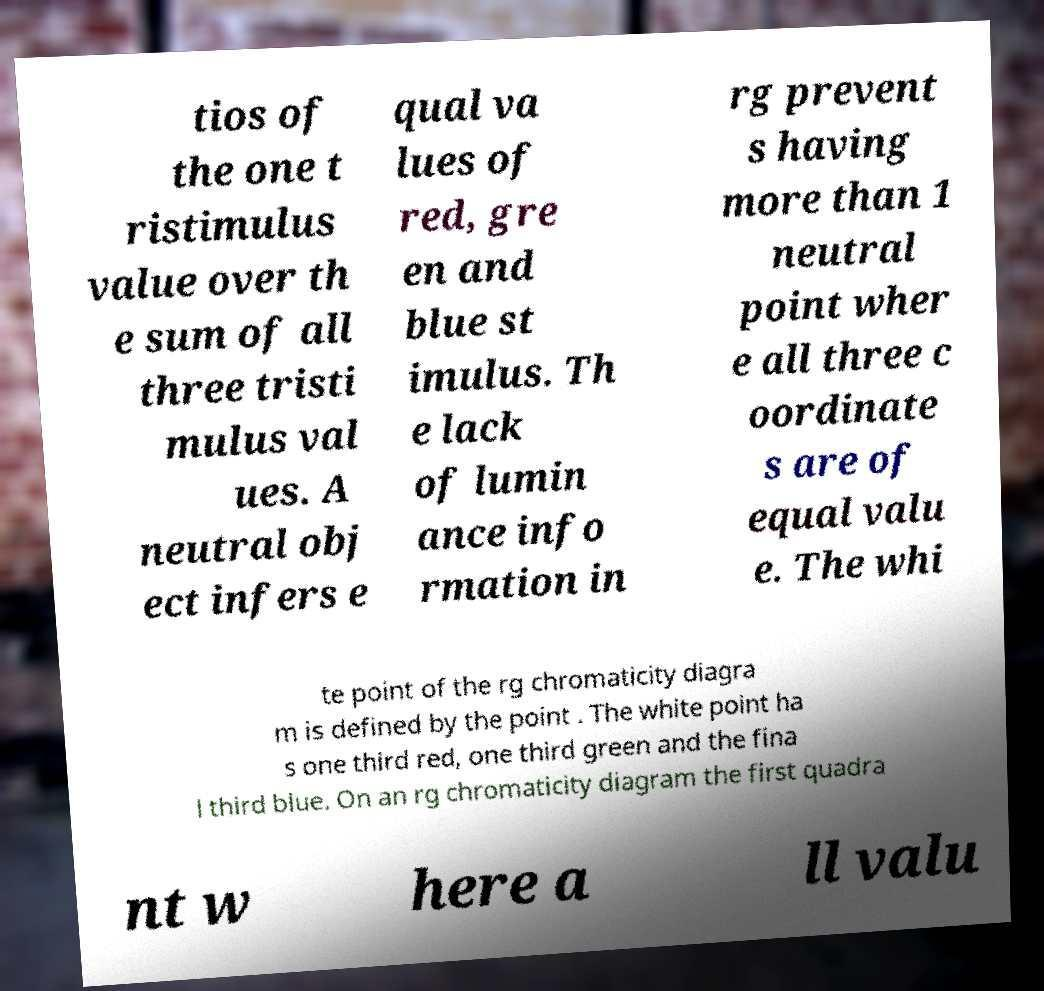Can you read and provide the text displayed in the image?This photo seems to have some interesting text. Can you extract and type it out for me? tios of the one t ristimulus value over th e sum of all three tristi mulus val ues. A neutral obj ect infers e qual va lues of red, gre en and blue st imulus. Th e lack of lumin ance info rmation in rg prevent s having more than 1 neutral point wher e all three c oordinate s are of equal valu e. The whi te point of the rg chromaticity diagra m is defined by the point . The white point ha s one third red, one third green and the fina l third blue. On an rg chromaticity diagram the first quadra nt w here a ll valu 